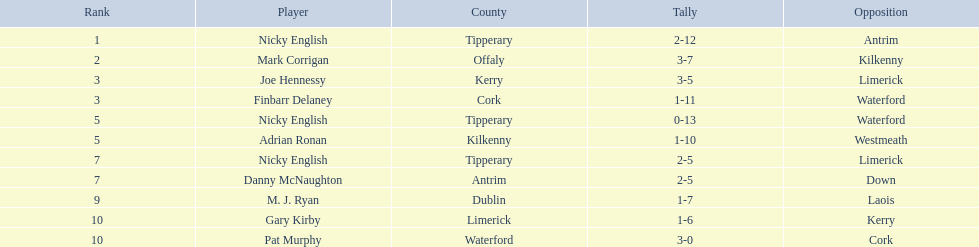Which player had the maximum rank? Nicky English. 